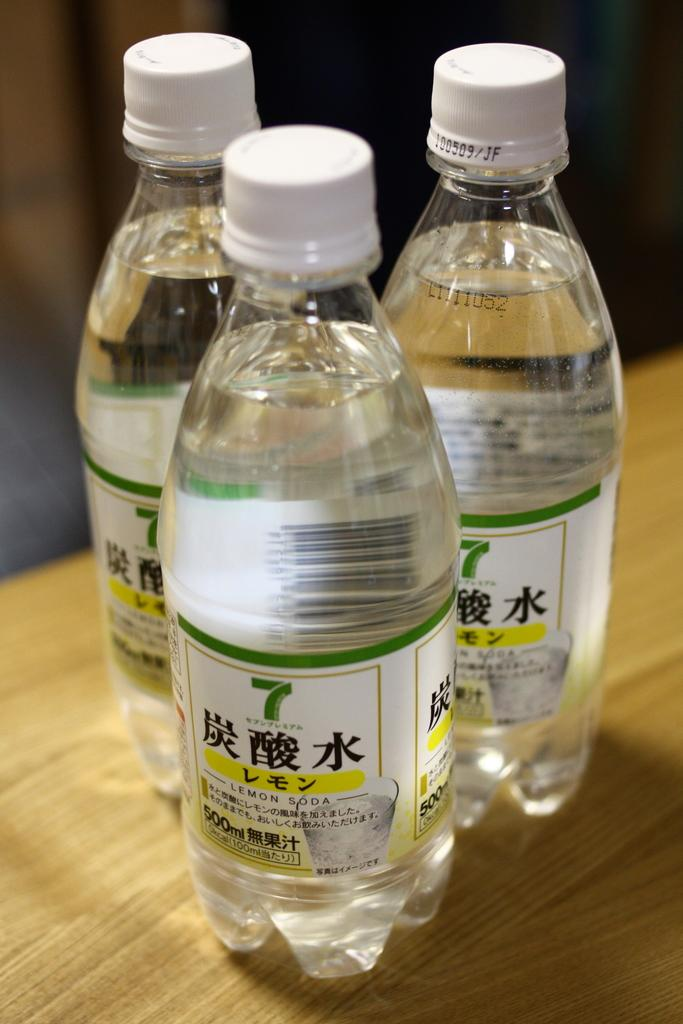<image>
Relay a brief, clear account of the picture shown. Three bottles of '7' label lemon soda are on a wood table. 